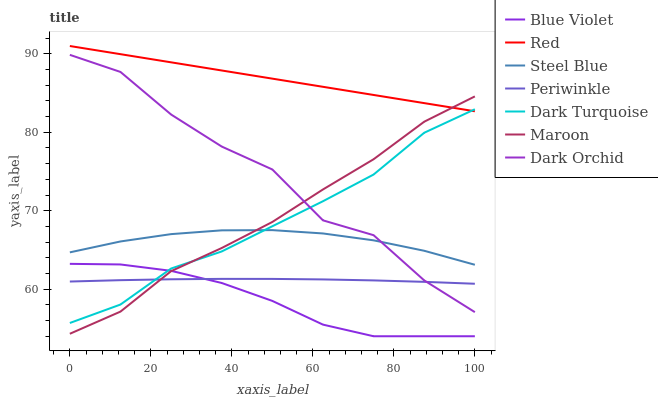Does Blue Violet have the minimum area under the curve?
Answer yes or no. Yes. Does Red have the maximum area under the curve?
Answer yes or no. Yes. Does Steel Blue have the minimum area under the curve?
Answer yes or no. No. Does Steel Blue have the maximum area under the curve?
Answer yes or no. No. Is Red the smoothest?
Answer yes or no. Yes. Is Dark Orchid the roughest?
Answer yes or no. Yes. Is Steel Blue the smoothest?
Answer yes or no. No. Is Steel Blue the roughest?
Answer yes or no. No. Does Blue Violet have the lowest value?
Answer yes or no. Yes. Does Steel Blue have the lowest value?
Answer yes or no. No. Does Red have the highest value?
Answer yes or no. Yes. Does Steel Blue have the highest value?
Answer yes or no. No. Is Blue Violet less than Steel Blue?
Answer yes or no. Yes. Is Red greater than Blue Violet?
Answer yes or no. Yes. Does Maroon intersect Dark Turquoise?
Answer yes or no. Yes. Is Maroon less than Dark Turquoise?
Answer yes or no. No. Is Maroon greater than Dark Turquoise?
Answer yes or no. No. Does Blue Violet intersect Steel Blue?
Answer yes or no. No. 